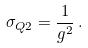<formula> <loc_0><loc_0><loc_500><loc_500>\sigma _ { Q 2 } = \frac { 1 } { g ^ { 2 } } \, .</formula> 